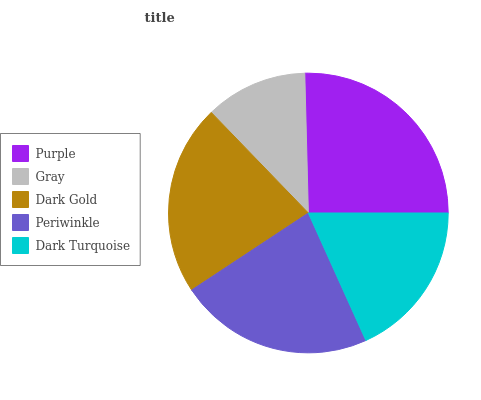Is Gray the minimum?
Answer yes or no. Yes. Is Purple the maximum?
Answer yes or no. Yes. Is Dark Gold the minimum?
Answer yes or no. No. Is Dark Gold the maximum?
Answer yes or no. No. Is Dark Gold greater than Gray?
Answer yes or no. Yes. Is Gray less than Dark Gold?
Answer yes or no. Yes. Is Gray greater than Dark Gold?
Answer yes or no. No. Is Dark Gold less than Gray?
Answer yes or no. No. Is Dark Gold the high median?
Answer yes or no. Yes. Is Dark Gold the low median?
Answer yes or no. Yes. Is Gray the high median?
Answer yes or no. No. Is Gray the low median?
Answer yes or no. No. 